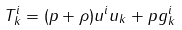Convert formula to latex. <formula><loc_0><loc_0><loc_500><loc_500>T ^ { i } _ { k } = ( p + \rho ) u ^ { i } u _ { k } + p g ^ { i } _ { k }</formula> 